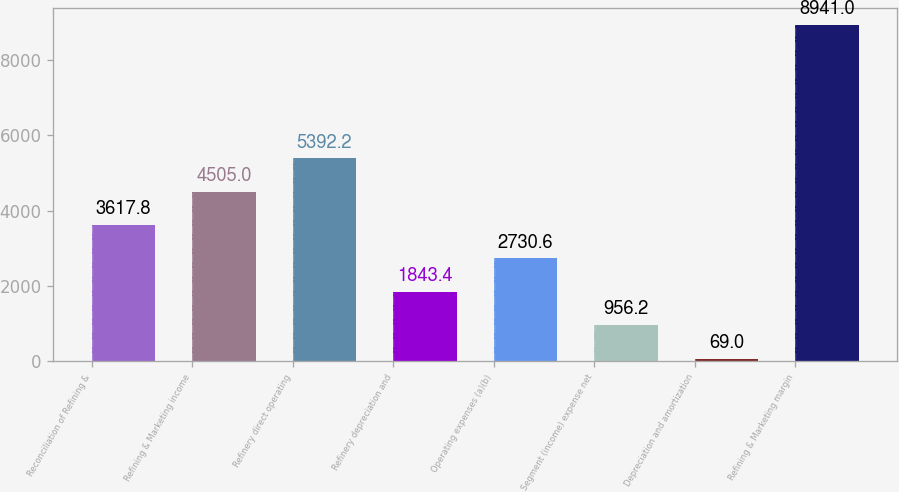Convert chart. <chart><loc_0><loc_0><loc_500><loc_500><bar_chart><fcel>Reconciliation of Refining &<fcel>Refining & Marketing income<fcel>Refinery direct operating<fcel>Refinery depreciation and<fcel>Operating expenses (a)(b)<fcel>Segment (income) expense net<fcel>Depreciation and amortization<fcel>Refining & Marketing margin<nl><fcel>3617.8<fcel>4505<fcel>5392.2<fcel>1843.4<fcel>2730.6<fcel>956.2<fcel>69<fcel>8941<nl></chart> 